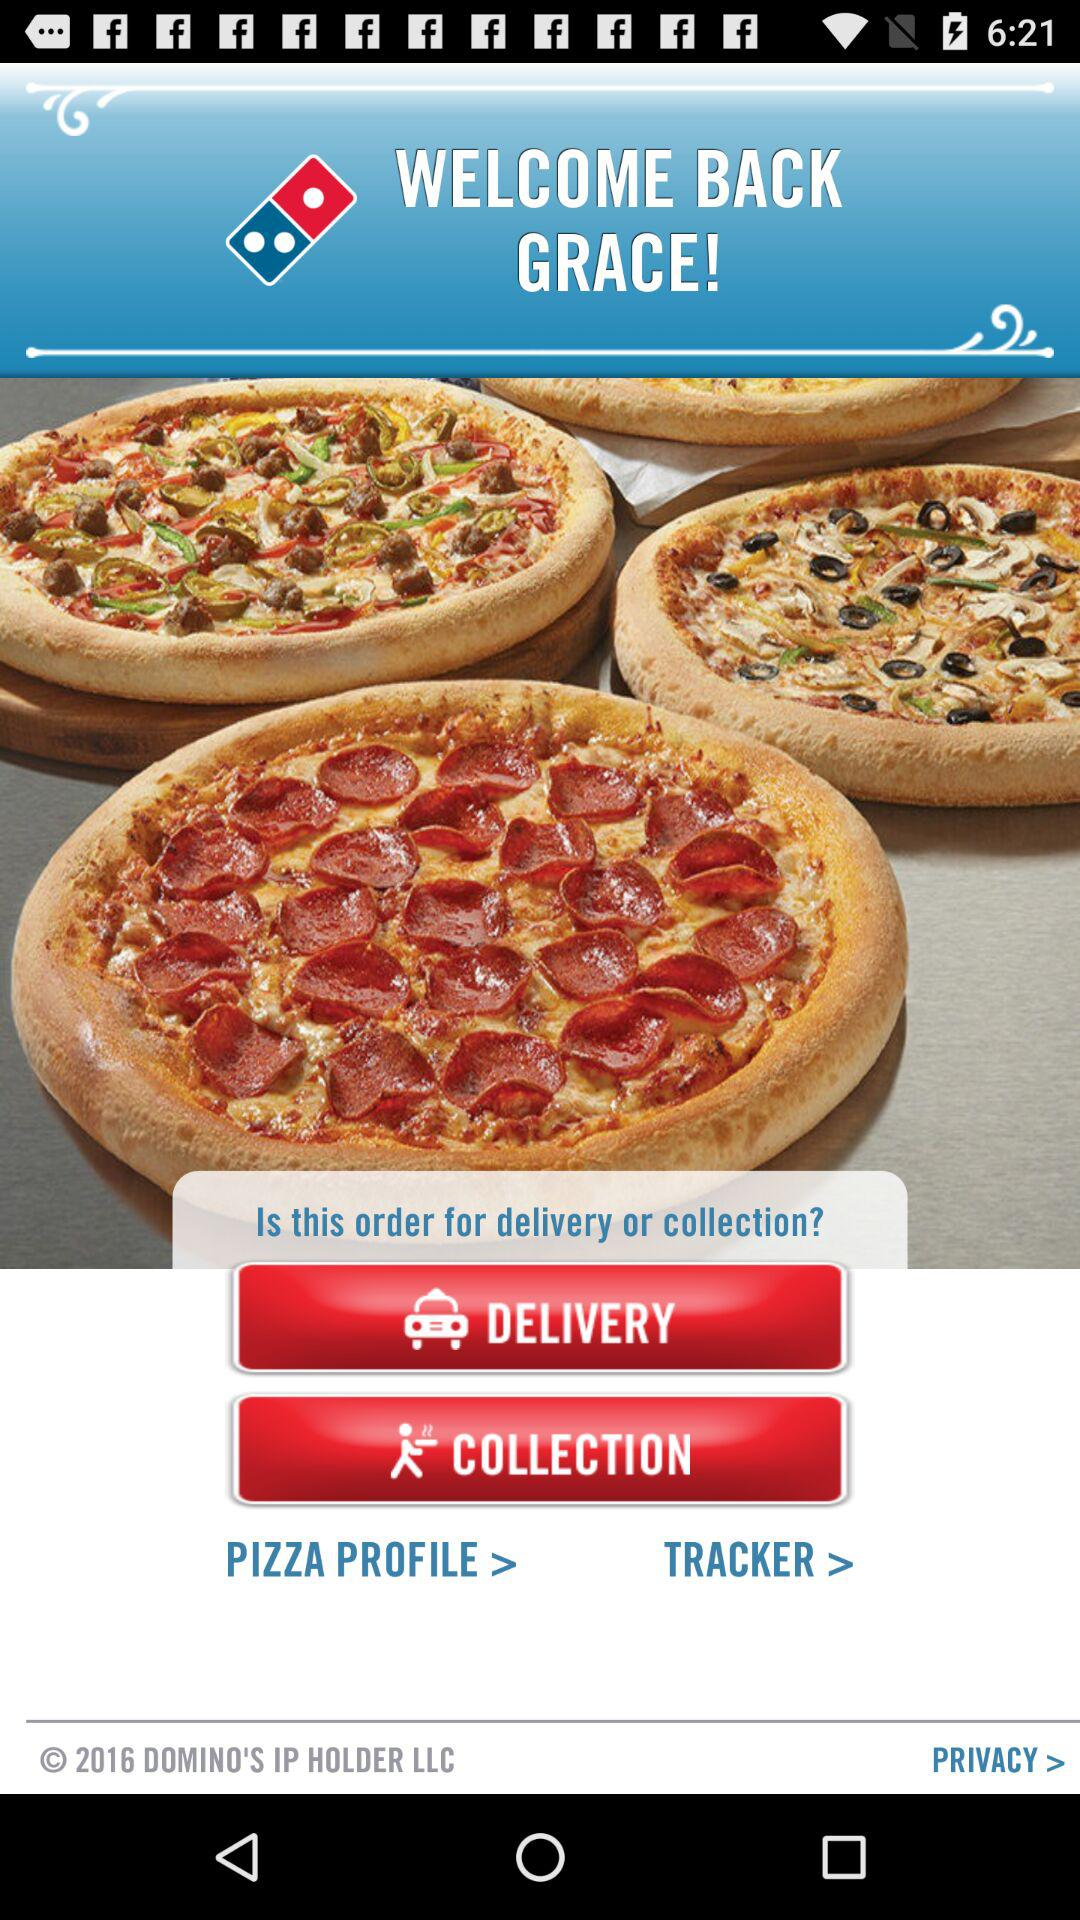What is the name of the user? The name of the user is Grace. 